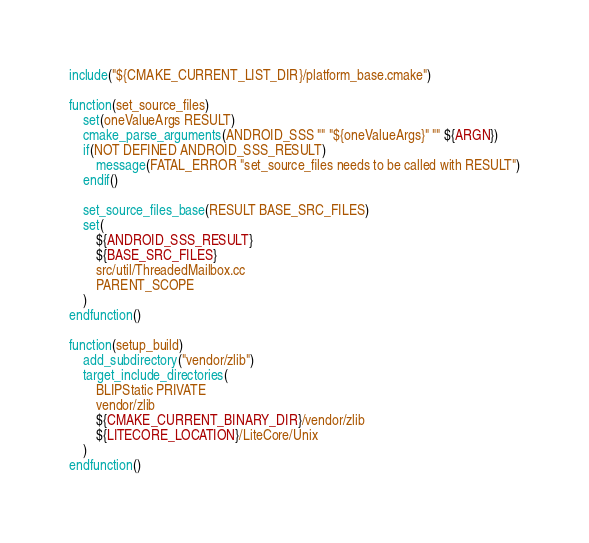<code> <loc_0><loc_0><loc_500><loc_500><_CMake_>include("${CMAKE_CURRENT_LIST_DIR}/platform_base.cmake")

function(set_source_files)
    set(oneValueArgs RESULT)
    cmake_parse_arguments(ANDROID_SSS "" "${oneValueArgs}" "" ${ARGN})
    if(NOT DEFINED ANDROID_SSS_RESULT)
        message(FATAL_ERROR "set_source_files needs to be called with RESULT")
    endif()

    set_source_files_base(RESULT BASE_SRC_FILES)
    set(
        ${ANDROID_SSS_RESULT}
        ${BASE_SRC_FILES}
        src/util/ThreadedMailbox.cc
        PARENT_SCOPE
    )
endfunction()

function(setup_build)
    add_subdirectory("vendor/zlib")
    target_include_directories(
        BLIPStatic PRIVATE
        vendor/zlib
        ${CMAKE_CURRENT_BINARY_DIR}/vendor/zlib
        ${LITECORE_LOCATION}/LiteCore/Unix
    )
endfunction()</code> 